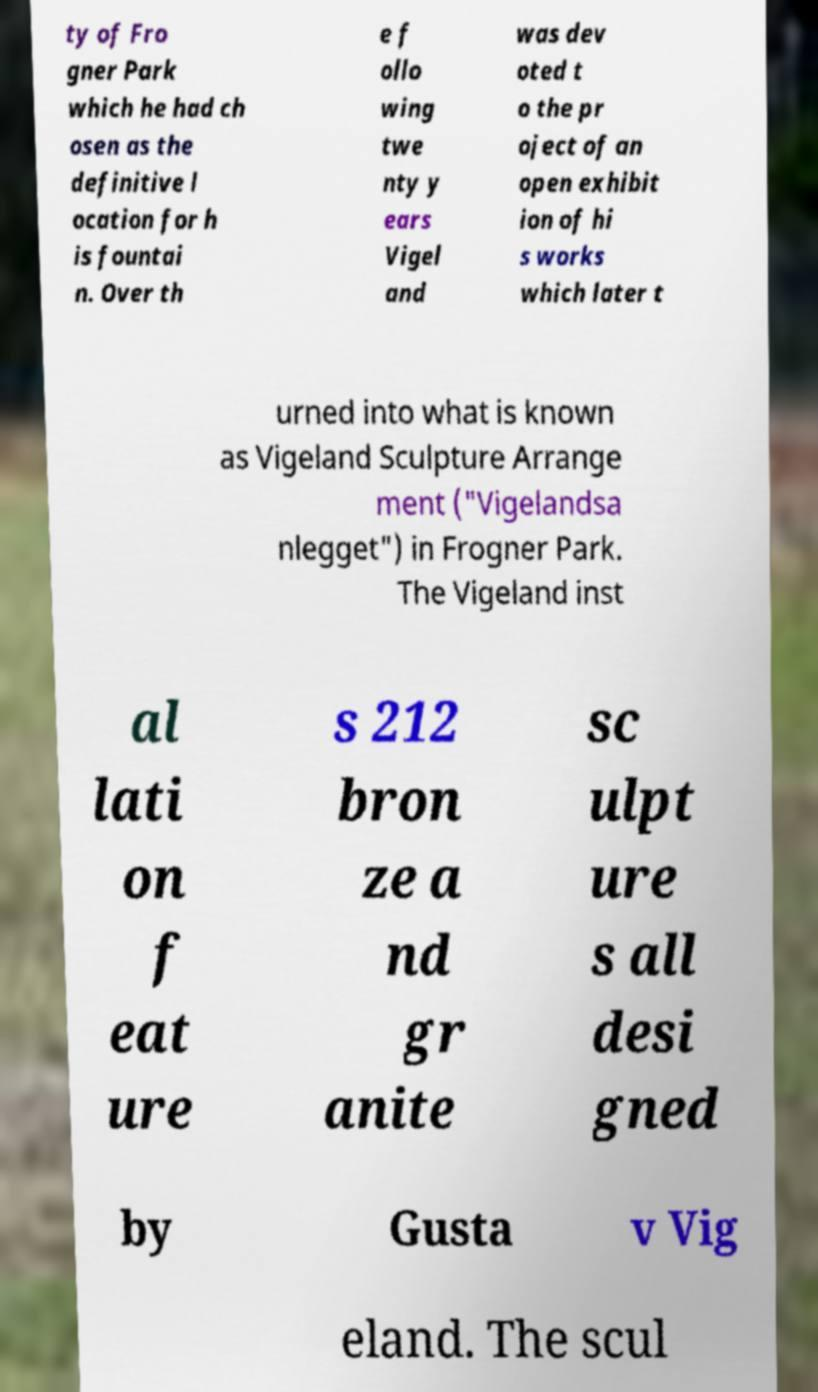Could you assist in decoding the text presented in this image and type it out clearly? ty of Fro gner Park which he had ch osen as the definitive l ocation for h is fountai n. Over th e f ollo wing twe nty y ears Vigel and was dev oted t o the pr oject of an open exhibit ion of hi s works which later t urned into what is known as Vigeland Sculpture Arrange ment ("Vigelandsa nlegget") in Frogner Park. The Vigeland inst al lati on f eat ure s 212 bron ze a nd gr anite sc ulpt ure s all desi gned by Gusta v Vig eland. The scul 